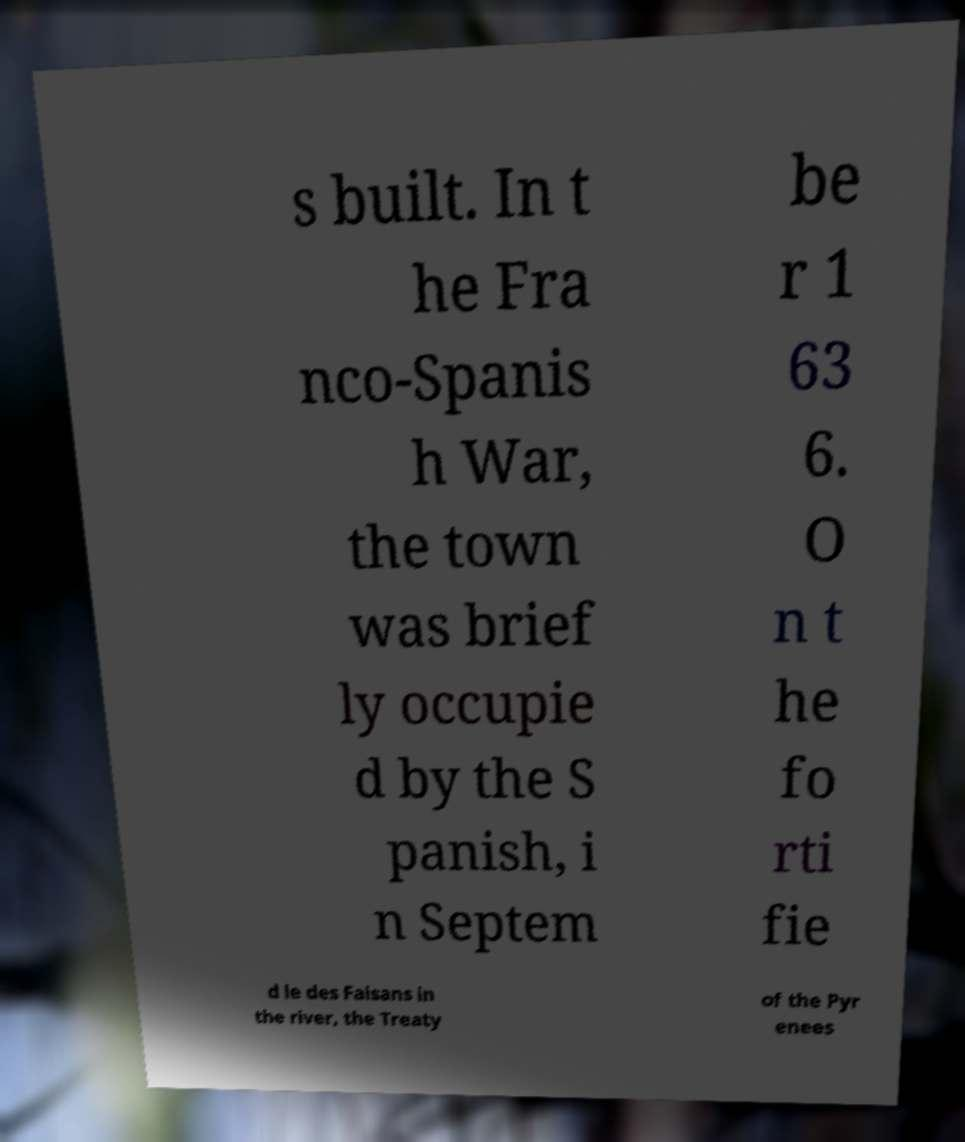For documentation purposes, I need the text within this image transcribed. Could you provide that? s built. In t he Fra nco-Spanis h War, the town was brief ly occupie d by the S panish, i n Septem be r 1 63 6. O n t he fo rti fie d le des Faisans in the river, the Treaty of the Pyr enees 